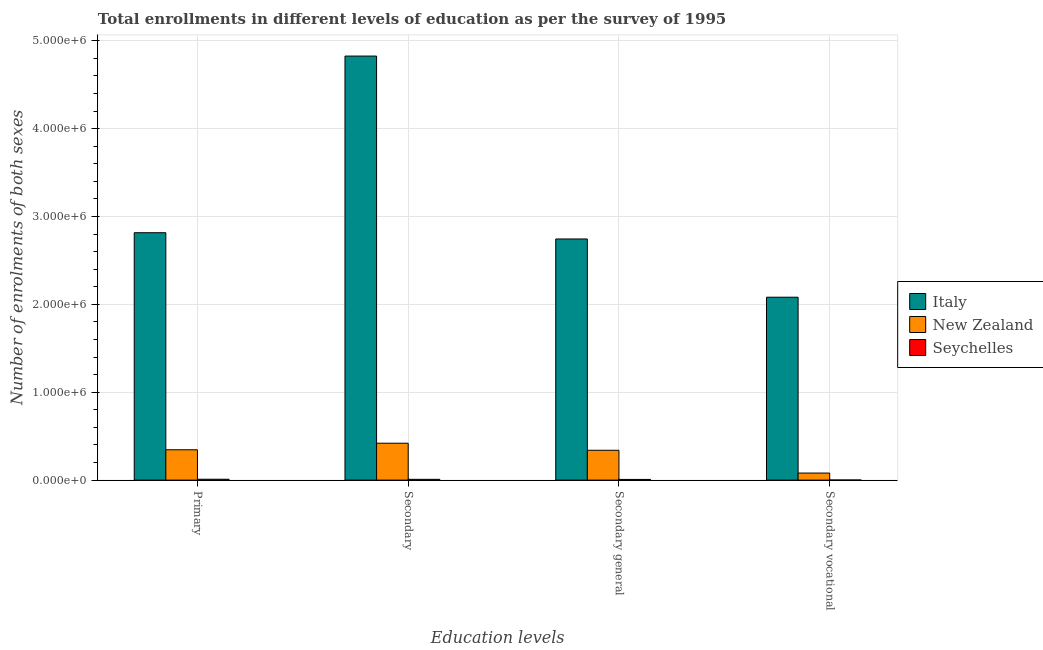How many different coloured bars are there?
Offer a very short reply. 3. How many groups of bars are there?
Give a very brief answer. 4. Are the number of bars per tick equal to the number of legend labels?
Provide a short and direct response. Yes. Are the number of bars on each tick of the X-axis equal?
Provide a short and direct response. Yes. How many bars are there on the 4th tick from the left?
Your response must be concise. 3. What is the label of the 4th group of bars from the left?
Your response must be concise. Secondary vocational. What is the number of enrolments in primary education in Italy?
Offer a very short reply. 2.82e+06. Across all countries, what is the maximum number of enrolments in secondary general education?
Ensure brevity in your answer.  2.74e+06. Across all countries, what is the minimum number of enrolments in secondary general education?
Ensure brevity in your answer.  7827. In which country was the number of enrolments in primary education maximum?
Provide a succinct answer. Italy. In which country was the number of enrolments in secondary vocational education minimum?
Provide a short and direct response. Seychelles. What is the total number of enrolments in secondary education in the graph?
Provide a succinct answer. 5.25e+06. What is the difference between the number of enrolments in primary education in Italy and that in New Zealand?
Your answer should be compact. 2.47e+06. What is the difference between the number of enrolments in primary education in New Zealand and the number of enrolments in secondary general education in Italy?
Provide a succinct answer. -2.40e+06. What is the average number of enrolments in secondary vocational education per country?
Your response must be concise. 7.21e+05. What is the difference between the number of enrolments in secondary general education and number of enrolments in primary education in Italy?
Your answer should be very brief. -7.14e+04. In how many countries, is the number of enrolments in secondary education greater than 4800000 ?
Your answer should be compact. 1. What is the ratio of the number of enrolments in secondary vocational education in Seychelles to that in New Zealand?
Keep it short and to the point. 0.01. Is the number of enrolments in primary education in Italy less than that in Seychelles?
Your answer should be compact. No. Is the difference between the number of enrolments in secondary vocational education in New Zealand and Seychelles greater than the difference between the number of enrolments in secondary general education in New Zealand and Seychelles?
Provide a succinct answer. No. What is the difference between the highest and the second highest number of enrolments in secondary vocational education?
Make the answer very short. 2.00e+06. What is the difference between the highest and the lowest number of enrolments in primary education?
Your answer should be compact. 2.81e+06. Is the sum of the number of enrolments in primary education in Italy and New Zealand greater than the maximum number of enrolments in secondary vocational education across all countries?
Ensure brevity in your answer.  Yes. What does the 3rd bar from the left in Secondary vocational represents?
Your answer should be very brief. Seychelles. What does the 1st bar from the right in Secondary vocational represents?
Provide a succinct answer. Seychelles. Is it the case that in every country, the sum of the number of enrolments in primary education and number of enrolments in secondary education is greater than the number of enrolments in secondary general education?
Provide a succinct answer. Yes. How many bars are there?
Ensure brevity in your answer.  12. Are all the bars in the graph horizontal?
Your answer should be very brief. No. What is the difference between two consecutive major ticks on the Y-axis?
Your response must be concise. 1.00e+06. Are the values on the major ticks of Y-axis written in scientific E-notation?
Your response must be concise. Yes. What is the title of the graph?
Ensure brevity in your answer.  Total enrollments in different levels of education as per the survey of 1995. What is the label or title of the X-axis?
Ensure brevity in your answer.  Education levels. What is the label or title of the Y-axis?
Offer a terse response. Number of enrolments of both sexes. What is the Number of enrolments of both sexes of Italy in Primary?
Give a very brief answer. 2.82e+06. What is the Number of enrolments of both sexes of New Zealand in Primary?
Provide a succinct answer. 3.45e+05. What is the Number of enrolments of both sexes of Seychelles in Primary?
Provide a short and direct response. 9885. What is the Number of enrolments of both sexes in Italy in Secondary?
Provide a short and direct response. 4.83e+06. What is the Number of enrolments of both sexes in New Zealand in Secondary?
Give a very brief answer. 4.20e+05. What is the Number of enrolments of both sexes in Seychelles in Secondary?
Your response must be concise. 8931. What is the Number of enrolments of both sexes of Italy in Secondary general?
Ensure brevity in your answer.  2.74e+06. What is the Number of enrolments of both sexes of New Zealand in Secondary general?
Offer a terse response. 3.40e+05. What is the Number of enrolments of both sexes of Seychelles in Secondary general?
Keep it short and to the point. 7827. What is the Number of enrolments of both sexes in Italy in Secondary vocational?
Provide a succinct answer. 2.08e+06. What is the Number of enrolments of both sexes in New Zealand in Secondary vocational?
Keep it short and to the point. 8.04e+04. What is the Number of enrolments of both sexes in Seychelles in Secondary vocational?
Keep it short and to the point. 1104. Across all Education levels, what is the maximum Number of enrolments of both sexes in Italy?
Make the answer very short. 4.83e+06. Across all Education levels, what is the maximum Number of enrolments of both sexes of New Zealand?
Provide a short and direct response. 4.20e+05. Across all Education levels, what is the maximum Number of enrolments of both sexes of Seychelles?
Make the answer very short. 9885. Across all Education levels, what is the minimum Number of enrolments of both sexes in Italy?
Your answer should be very brief. 2.08e+06. Across all Education levels, what is the minimum Number of enrolments of both sexes of New Zealand?
Offer a terse response. 8.04e+04. Across all Education levels, what is the minimum Number of enrolments of both sexes in Seychelles?
Your answer should be very brief. 1104. What is the total Number of enrolments of both sexes of Italy in the graph?
Ensure brevity in your answer.  1.25e+07. What is the total Number of enrolments of both sexes in New Zealand in the graph?
Offer a very short reply. 1.19e+06. What is the total Number of enrolments of both sexes in Seychelles in the graph?
Your answer should be very brief. 2.77e+04. What is the difference between the Number of enrolments of both sexes in Italy in Primary and that in Secondary?
Provide a short and direct response. -2.01e+06. What is the difference between the Number of enrolments of both sexes of New Zealand in Primary and that in Secondary?
Offer a terse response. -7.48e+04. What is the difference between the Number of enrolments of both sexes in Seychelles in Primary and that in Secondary?
Offer a very short reply. 954. What is the difference between the Number of enrolments of both sexes in Italy in Primary and that in Secondary general?
Your answer should be very brief. 7.14e+04. What is the difference between the Number of enrolments of both sexes of New Zealand in Primary and that in Secondary general?
Ensure brevity in your answer.  5576. What is the difference between the Number of enrolments of both sexes in Seychelles in Primary and that in Secondary general?
Ensure brevity in your answer.  2058. What is the difference between the Number of enrolments of both sexes of Italy in Primary and that in Secondary vocational?
Your response must be concise. 7.34e+05. What is the difference between the Number of enrolments of both sexes in New Zealand in Primary and that in Secondary vocational?
Offer a terse response. 2.65e+05. What is the difference between the Number of enrolments of both sexes of Seychelles in Primary and that in Secondary vocational?
Ensure brevity in your answer.  8781. What is the difference between the Number of enrolments of both sexes in Italy in Secondary and that in Secondary general?
Offer a very short reply. 2.08e+06. What is the difference between the Number of enrolments of both sexes in New Zealand in Secondary and that in Secondary general?
Keep it short and to the point. 8.04e+04. What is the difference between the Number of enrolments of both sexes of Seychelles in Secondary and that in Secondary general?
Give a very brief answer. 1104. What is the difference between the Number of enrolments of both sexes of Italy in Secondary and that in Secondary vocational?
Make the answer very short. 2.74e+06. What is the difference between the Number of enrolments of both sexes of New Zealand in Secondary and that in Secondary vocational?
Your response must be concise. 3.40e+05. What is the difference between the Number of enrolments of both sexes of Seychelles in Secondary and that in Secondary vocational?
Ensure brevity in your answer.  7827. What is the difference between the Number of enrolments of both sexes in Italy in Secondary general and that in Secondary vocational?
Provide a succinct answer. 6.63e+05. What is the difference between the Number of enrolments of both sexes of New Zealand in Secondary general and that in Secondary vocational?
Make the answer very short. 2.59e+05. What is the difference between the Number of enrolments of both sexes of Seychelles in Secondary general and that in Secondary vocational?
Ensure brevity in your answer.  6723. What is the difference between the Number of enrolments of both sexes in Italy in Primary and the Number of enrolments of both sexes in New Zealand in Secondary?
Provide a succinct answer. 2.40e+06. What is the difference between the Number of enrolments of both sexes of Italy in Primary and the Number of enrolments of both sexes of Seychelles in Secondary?
Ensure brevity in your answer.  2.81e+06. What is the difference between the Number of enrolments of both sexes in New Zealand in Primary and the Number of enrolments of both sexes in Seychelles in Secondary?
Provide a succinct answer. 3.36e+05. What is the difference between the Number of enrolments of both sexes in Italy in Primary and the Number of enrolments of both sexes in New Zealand in Secondary general?
Offer a very short reply. 2.48e+06. What is the difference between the Number of enrolments of both sexes in Italy in Primary and the Number of enrolments of both sexes in Seychelles in Secondary general?
Your response must be concise. 2.81e+06. What is the difference between the Number of enrolments of both sexes in New Zealand in Primary and the Number of enrolments of both sexes in Seychelles in Secondary general?
Give a very brief answer. 3.37e+05. What is the difference between the Number of enrolments of both sexes of Italy in Primary and the Number of enrolments of both sexes of New Zealand in Secondary vocational?
Your response must be concise. 2.74e+06. What is the difference between the Number of enrolments of both sexes in Italy in Primary and the Number of enrolments of both sexes in Seychelles in Secondary vocational?
Make the answer very short. 2.81e+06. What is the difference between the Number of enrolments of both sexes of New Zealand in Primary and the Number of enrolments of both sexes of Seychelles in Secondary vocational?
Keep it short and to the point. 3.44e+05. What is the difference between the Number of enrolments of both sexes of Italy in Secondary and the Number of enrolments of both sexes of New Zealand in Secondary general?
Your response must be concise. 4.49e+06. What is the difference between the Number of enrolments of both sexes in Italy in Secondary and the Number of enrolments of both sexes in Seychelles in Secondary general?
Your answer should be very brief. 4.82e+06. What is the difference between the Number of enrolments of both sexes of New Zealand in Secondary and the Number of enrolments of both sexes of Seychelles in Secondary general?
Offer a very short reply. 4.12e+05. What is the difference between the Number of enrolments of both sexes in Italy in Secondary and the Number of enrolments of both sexes in New Zealand in Secondary vocational?
Your answer should be compact. 4.75e+06. What is the difference between the Number of enrolments of both sexes of Italy in Secondary and the Number of enrolments of both sexes of Seychelles in Secondary vocational?
Ensure brevity in your answer.  4.82e+06. What is the difference between the Number of enrolments of both sexes in New Zealand in Secondary and the Number of enrolments of both sexes in Seychelles in Secondary vocational?
Give a very brief answer. 4.19e+05. What is the difference between the Number of enrolments of both sexes in Italy in Secondary general and the Number of enrolments of both sexes in New Zealand in Secondary vocational?
Your response must be concise. 2.66e+06. What is the difference between the Number of enrolments of both sexes of Italy in Secondary general and the Number of enrolments of both sexes of Seychelles in Secondary vocational?
Keep it short and to the point. 2.74e+06. What is the difference between the Number of enrolments of both sexes of New Zealand in Secondary general and the Number of enrolments of both sexes of Seychelles in Secondary vocational?
Your answer should be very brief. 3.39e+05. What is the average Number of enrolments of both sexes in Italy per Education levels?
Keep it short and to the point. 3.12e+06. What is the average Number of enrolments of both sexes of New Zealand per Education levels?
Ensure brevity in your answer.  2.96e+05. What is the average Number of enrolments of both sexes of Seychelles per Education levels?
Your answer should be compact. 6936.75. What is the difference between the Number of enrolments of both sexes in Italy and Number of enrolments of both sexes in New Zealand in Primary?
Make the answer very short. 2.47e+06. What is the difference between the Number of enrolments of both sexes of Italy and Number of enrolments of both sexes of Seychelles in Primary?
Give a very brief answer. 2.81e+06. What is the difference between the Number of enrolments of both sexes of New Zealand and Number of enrolments of both sexes of Seychelles in Primary?
Give a very brief answer. 3.35e+05. What is the difference between the Number of enrolments of both sexes of Italy and Number of enrolments of both sexes of New Zealand in Secondary?
Make the answer very short. 4.41e+06. What is the difference between the Number of enrolments of both sexes in Italy and Number of enrolments of both sexes in Seychelles in Secondary?
Make the answer very short. 4.82e+06. What is the difference between the Number of enrolments of both sexes of New Zealand and Number of enrolments of both sexes of Seychelles in Secondary?
Keep it short and to the point. 4.11e+05. What is the difference between the Number of enrolments of both sexes of Italy and Number of enrolments of both sexes of New Zealand in Secondary general?
Provide a short and direct response. 2.40e+06. What is the difference between the Number of enrolments of both sexes of Italy and Number of enrolments of both sexes of Seychelles in Secondary general?
Your answer should be very brief. 2.74e+06. What is the difference between the Number of enrolments of both sexes of New Zealand and Number of enrolments of both sexes of Seychelles in Secondary general?
Your answer should be compact. 3.32e+05. What is the difference between the Number of enrolments of both sexes in Italy and Number of enrolments of both sexes in New Zealand in Secondary vocational?
Give a very brief answer. 2.00e+06. What is the difference between the Number of enrolments of both sexes of Italy and Number of enrolments of both sexes of Seychelles in Secondary vocational?
Provide a short and direct response. 2.08e+06. What is the difference between the Number of enrolments of both sexes in New Zealand and Number of enrolments of both sexes in Seychelles in Secondary vocational?
Offer a very short reply. 7.93e+04. What is the ratio of the Number of enrolments of both sexes of Italy in Primary to that in Secondary?
Provide a succinct answer. 0.58. What is the ratio of the Number of enrolments of both sexes in New Zealand in Primary to that in Secondary?
Your response must be concise. 0.82. What is the ratio of the Number of enrolments of both sexes of Seychelles in Primary to that in Secondary?
Your answer should be compact. 1.11. What is the ratio of the Number of enrolments of both sexes of New Zealand in Primary to that in Secondary general?
Your answer should be very brief. 1.02. What is the ratio of the Number of enrolments of both sexes of Seychelles in Primary to that in Secondary general?
Provide a succinct answer. 1.26. What is the ratio of the Number of enrolments of both sexes in Italy in Primary to that in Secondary vocational?
Provide a succinct answer. 1.35. What is the ratio of the Number of enrolments of both sexes in New Zealand in Primary to that in Secondary vocational?
Make the answer very short. 4.29. What is the ratio of the Number of enrolments of both sexes of Seychelles in Primary to that in Secondary vocational?
Ensure brevity in your answer.  8.95. What is the ratio of the Number of enrolments of both sexes of Italy in Secondary to that in Secondary general?
Offer a terse response. 1.76. What is the ratio of the Number of enrolments of both sexes in New Zealand in Secondary to that in Secondary general?
Give a very brief answer. 1.24. What is the ratio of the Number of enrolments of both sexes in Seychelles in Secondary to that in Secondary general?
Offer a terse response. 1.14. What is the ratio of the Number of enrolments of both sexes in Italy in Secondary to that in Secondary vocational?
Give a very brief answer. 2.32. What is the ratio of the Number of enrolments of both sexes in New Zealand in Secondary to that in Secondary vocational?
Provide a succinct answer. 5.22. What is the ratio of the Number of enrolments of both sexes of Seychelles in Secondary to that in Secondary vocational?
Your answer should be very brief. 8.09. What is the ratio of the Number of enrolments of both sexes in Italy in Secondary general to that in Secondary vocational?
Offer a terse response. 1.32. What is the ratio of the Number of enrolments of both sexes in New Zealand in Secondary general to that in Secondary vocational?
Offer a terse response. 4.22. What is the ratio of the Number of enrolments of both sexes in Seychelles in Secondary general to that in Secondary vocational?
Offer a very short reply. 7.09. What is the difference between the highest and the second highest Number of enrolments of both sexes in Italy?
Your answer should be compact. 2.01e+06. What is the difference between the highest and the second highest Number of enrolments of both sexes in New Zealand?
Offer a terse response. 7.48e+04. What is the difference between the highest and the second highest Number of enrolments of both sexes in Seychelles?
Make the answer very short. 954. What is the difference between the highest and the lowest Number of enrolments of both sexes of Italy?
Offer a very short reply. 2.74e+06. What is the difference between the highest and the lowest Number of enrolments of both sexes of New Zealand?
Give a very brief answer. 3.40e+05. What is the difference between the highest and the lowest Number of enrolments of both sexes of Seychelles?
Keep it short and to the point. 8781. 